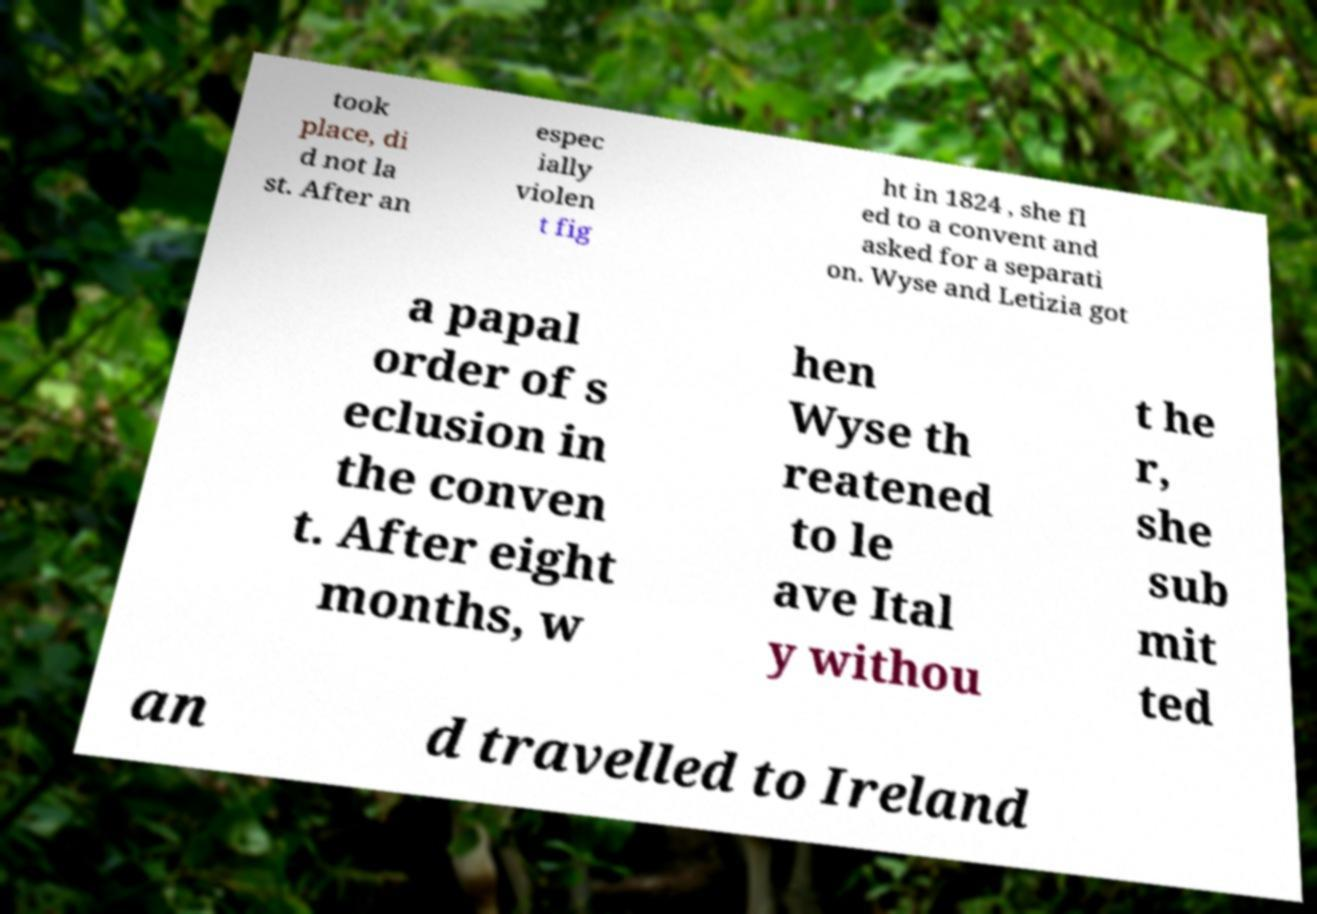For documentation purposes, I need the text within this image transcribed. Could you provide that? took place, di d not la st. After an espec ially violen t fig ht in 1824 , she fl ed to a convent and asked for a separati on. Wyse and Letizia got a papal order of s eclusion in the conven t. After eight months, w hen Wyse th reatened to le ave Ital y withou t he r, she sub mit ted an d travelled to Ireland 